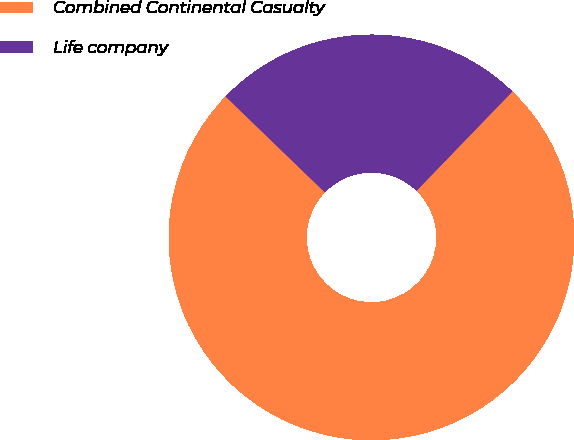<chart> <loc_0><loc_0><loc_500><loc_500><pie_chart><fcel>Combined Continental Casualty<fcel>Life company<nl><fcel>75.0%<fcel>25.0%<nl></chart> 